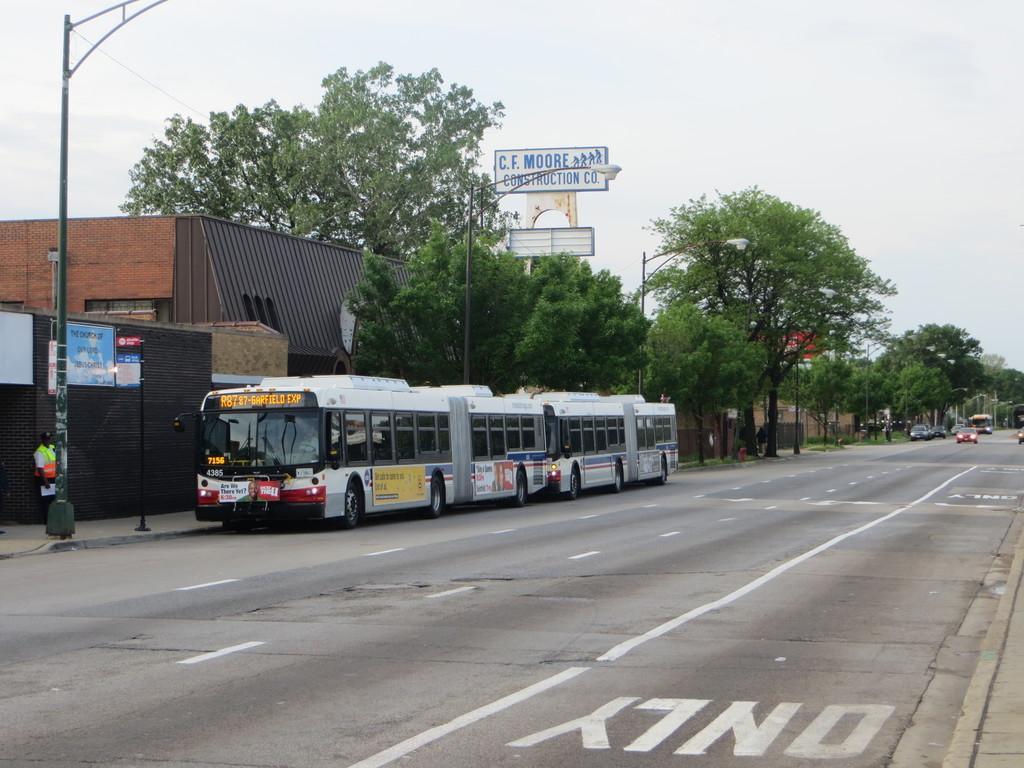How would you summarize this image in a sentence or two? In this picture I can see couple of buses and buildings and trees and few vehicles moving on the road and hoardings with some text and a man standing and i can see cloudy sky and few pole lights. 